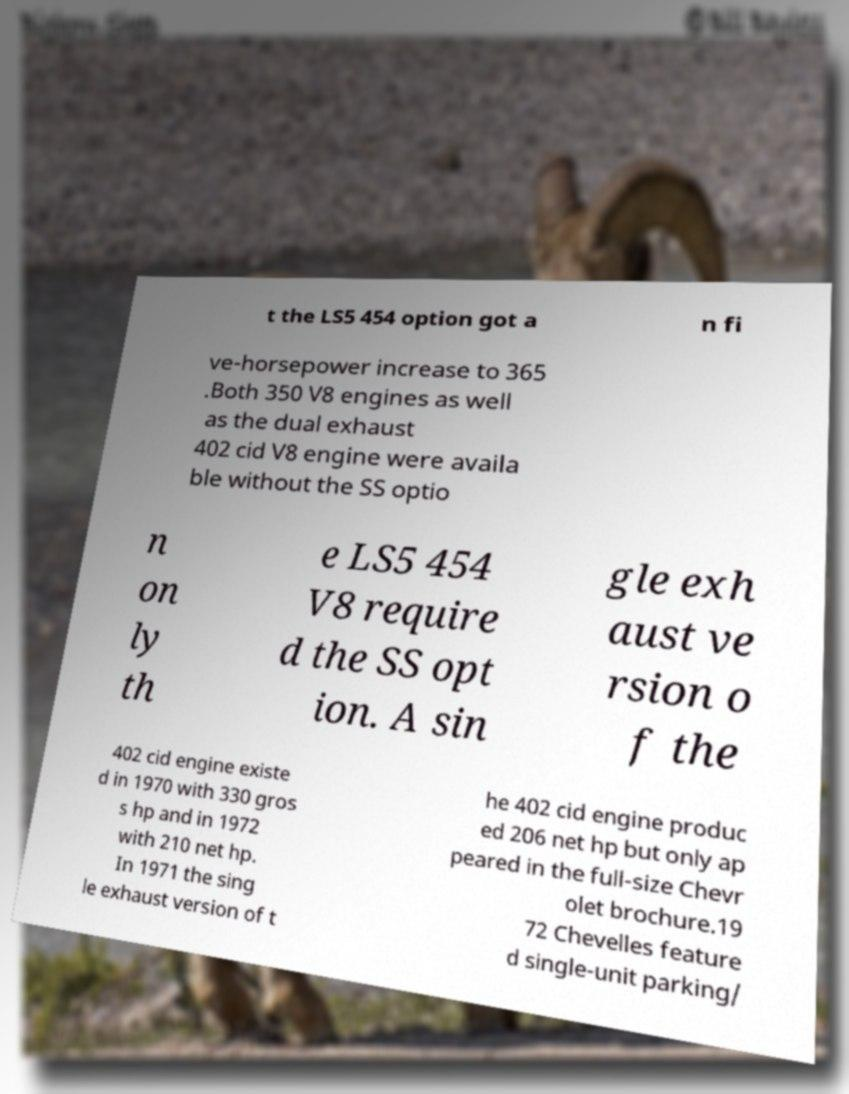Could you assist in decoding the text presented in this image and type it out clearly? t the LS5 454 option got a n fi ve-horsepower increase to 365 .Both 350 V8 engines as well as the dual exhaust 402 cid V8 engine were availa ble without the SS optio n on ly th e LS5 454 V8 require d the SS opt ion. A sin gle exh aust ve rsion o f the 402 cid engine existe d in 1970 with 330 gros s hp and in 1972 with 210 net hp. In 1971 the sing le exhaust version of t he 402 cid engine produc ed 206 net hp but only ap peared in the full-size Chevr olet brochure.19 72 Chevelles feature d single-unit parking/ 